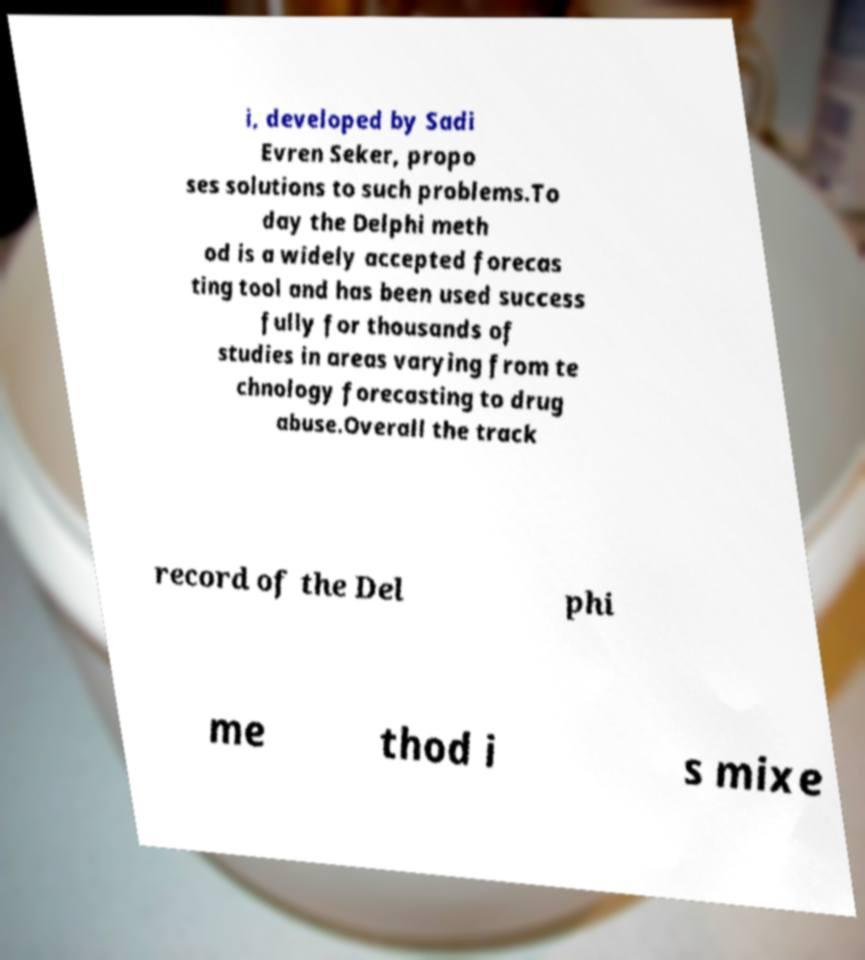Please read and relay the text visible in this image. What does it say? i, developed by Sadi Evren Seker, propo ses solutions to such problems.To day the Delphi meth od is a widely accepted forecas ting tool and has been used success fully for thousands of studies in areas varying from te chnology forecasting to drug abuse.Overall the track record of the Del phi me thod i s mixe 